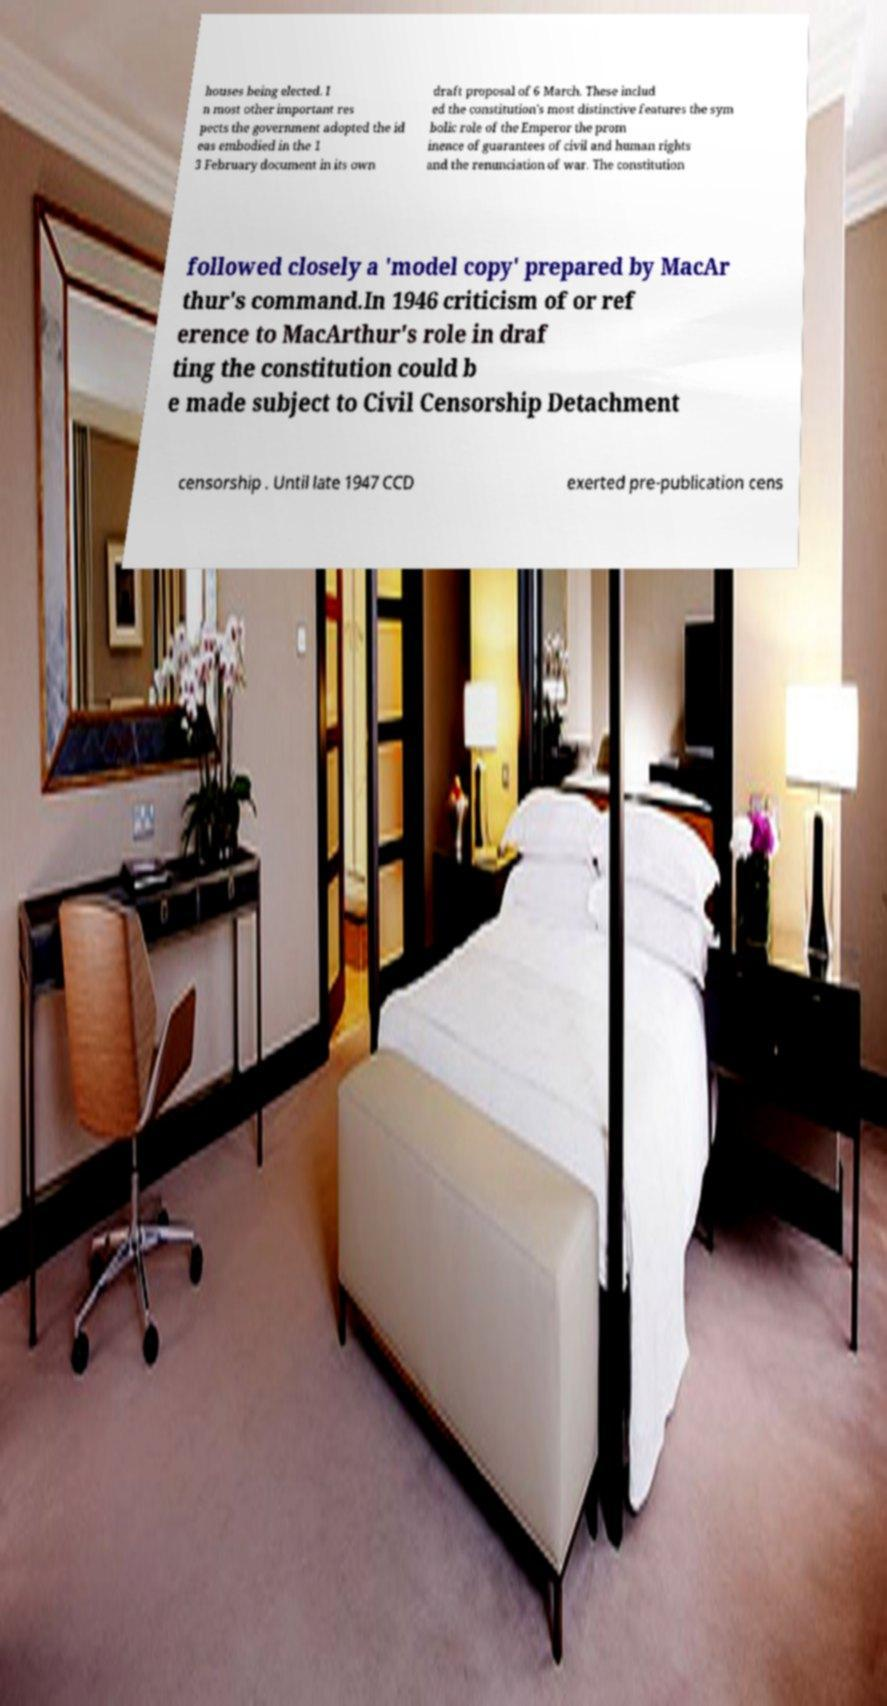What messages or text are displayed in this image? I need them in a readable, typed format. houses being elected. I n most other important res pects the government adopted the id eas embodied in the 1 3 February document in its own draft proposal of 6 March. These includ ed the constitution's most distinctive features the sym bolic role of the Emperor the prom inence of guarantees of civil and human rights and the renunciation of war. The constitution followed closely a 'model copy' prepared by MacAr thur's command.In 1946 criticism of or ref erence to MacArthur's role in draf ting the constitution could b e made subject to Civil Censorship Detachment censorship . Until late 1947 CCD exerted pre-publication cens 